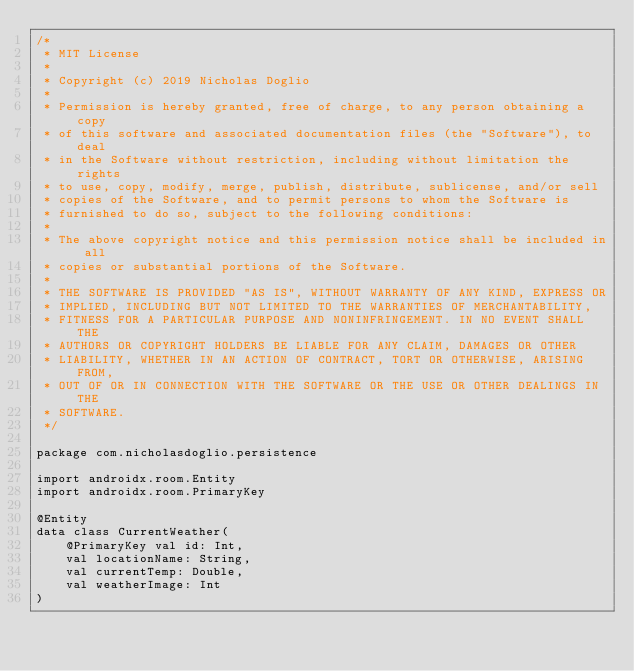<code> <loc_0><loc_0><loc_500><loc_500><_Kotlin_>/*
 * MIT License
 *
 * Copyright (c) 2019 Nicholas Doglio
 *
 * Permission is hereby granted, free of charge, to any person obtaining a copy
 * of this software and associated documentation files (the "Software"), to deal
 * in the Software without restriction, including without limitation the rights
 * to use, copy, modify, merge, publish, distribute, sublicense, and/or sell
 * copies of the Software, and to permit persons to whom the Software is
 * furnished to do so, subject to the following conditions:
 *
 * The above copyright notice and this permission notice shall be included in all
 * copies or substantial portions of the Software.
 *
 * THE SOFTWARE IS PROVIDED "AS IS", WITHOUT WARRANTY OF ANY KIND, EXPRESS OR
 * IMPLIED, INCLUDING BUT NOT LIMITED TO THE WARRANTIES OF MERCHANTABILITY,
 * FITNESS FOR A PARTICULAR PURPOSE AND NONINFRINGEMENT. IN NO EVENT SHALL THE
 * AUTHORS OR COPYRIGHT HOLDERS BE LIABLE FOR ANY CLAIM, DAMAGES OR OTHER
 * LIABILITY, WHETHER IN AN ACTION OF CONTRACT, TORT OR OTHERWISE, ARISING FROM,
 * OUT OF OR IN CONNECTION WITH THE SOFTWARE OR THE USE OR OTHER DEALINGS IN THE
 * SOFTWARE.
 */

package com.nicholasdoglio.persistence

import androidx.room.Entity
import androidx.room.PrimaryKey

@Entity
data class CurrentWeather(
    @PrimaryKey val id: Int,
    val locationName: String,
    val currentTemp: Double,
    val weatherImage: Int
)</code> 